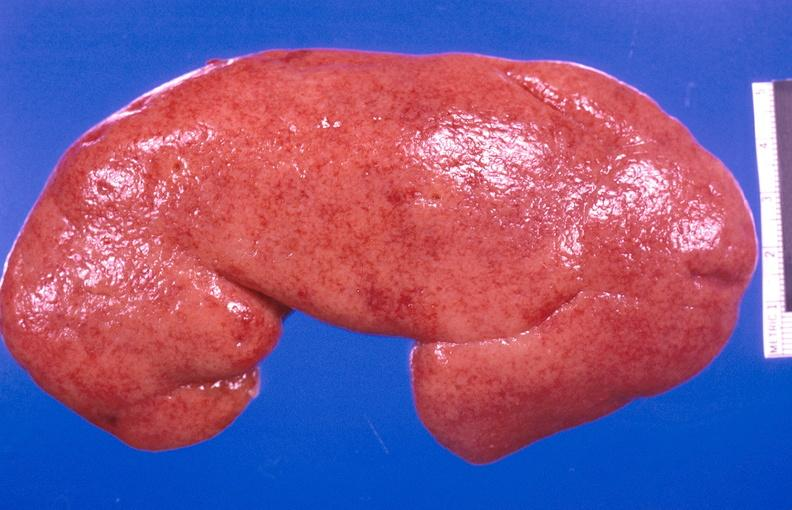does this image show kidney aspergillosis?
Answer the question using a single word or phrase. Yes 